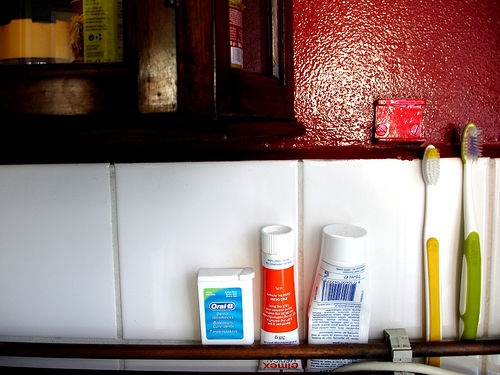Describe the objects in this image and their specific colors. I can see toothbrush in black, white, and olive tones and toothbrush in black, white, gold, darkgray, and beige tones in this image. 